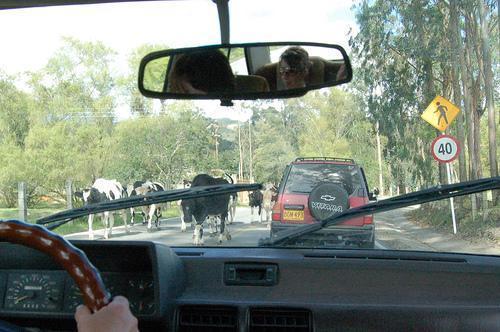How many cars can you see?
Give a very brief answer. 2. How many keyboards are on the desk?
Give a very brief answer. 0. 